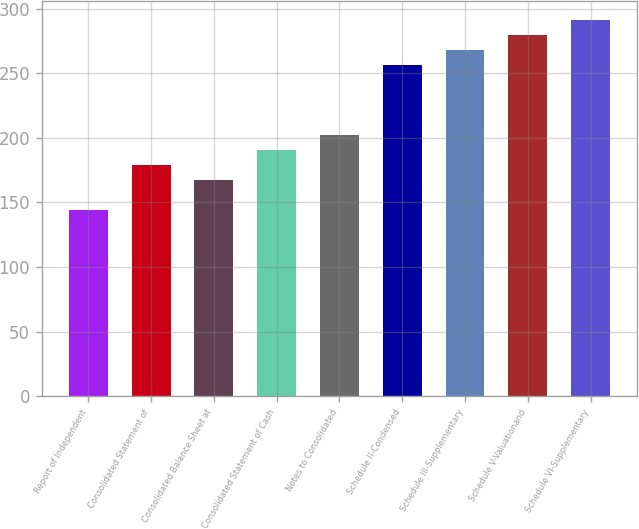Convert chart. <chart><loc_0><loc_0><loc_500><loc_500><bar_chart><fcel>Report of Independent<fcel>Consolidated Statement of<fcel>Consolidated Balance Sheet at<fcel>Consolidated Statement of Cash<fcel>Notes to Consolidated<fcel>Schedule II-Condensed<fcel>Schedule III-Supplementary<fcel>Schedule V-Valuationand<fcel>Schedule VI-Supplementary<nl><fcel>144<fcel>179.1<fcel>167.4<fcel>190.8<fcel>202.5<fcel>256<fcel>267.7<fcel>279.4<fcel>291.1<nl></chart> 